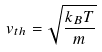<formula> <loc_0><loc_0><loc_500><loc_500>v _ { t h } = \sqrt { \frac { k _ { B } T } { m } }</formula> 